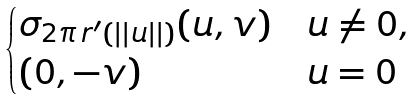Convert formula to latex. <formula><loc_0><loc_0><loc_500><loc_500>\begin{cases} \sigma _ { 2 \pi \, r ^ { \prime } ( | | u | | ) } ( u , v ) & u \neq 0 , \\ ( 0 , - v ) & u = 0 \end{cases}</formula> 